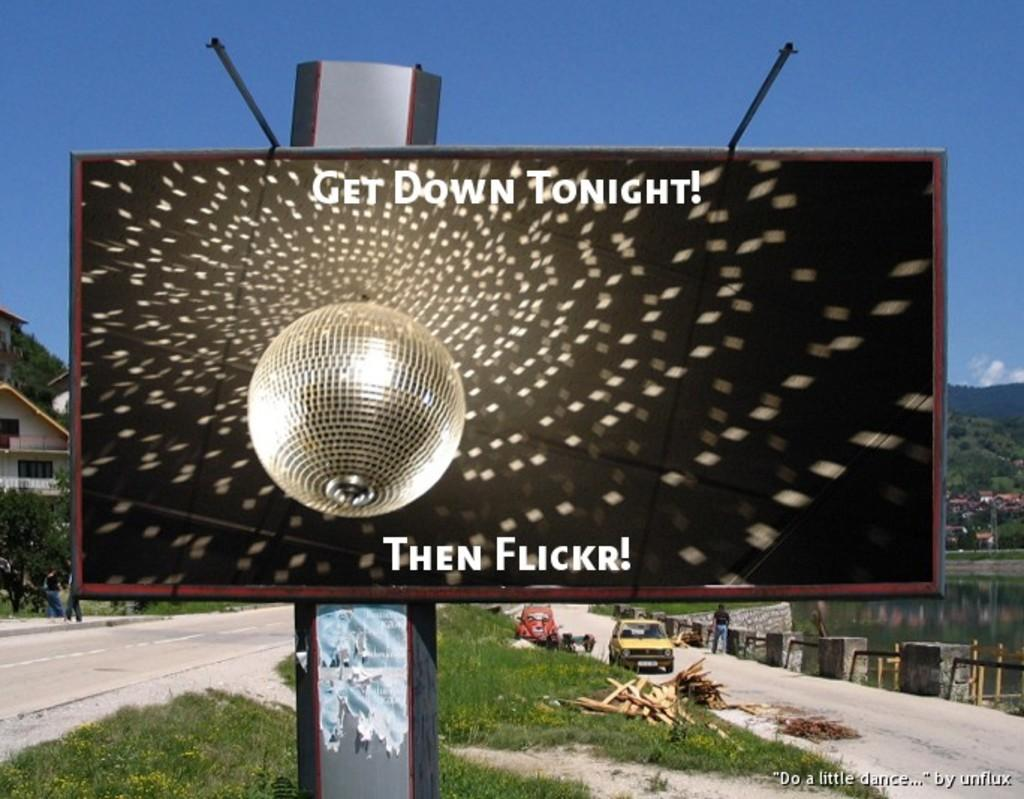<image>
Describe the image concisely. A disco ball displayed on a sign with the text "Get Down Tonight!". 